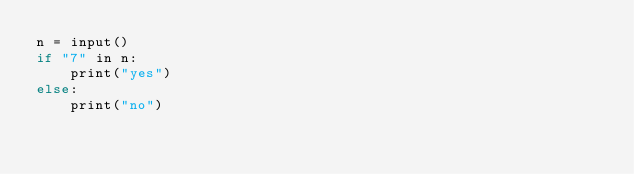<code> <loc_0><loc_0><loc_500><loc_500><_C_>n = input()
if "7" in n:
    print("yes")
else:
    print("no")
	</code> 